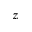Convert formula to latex. <formula><loc_0><loc_0><loc_500><loc_500>z</formula> 